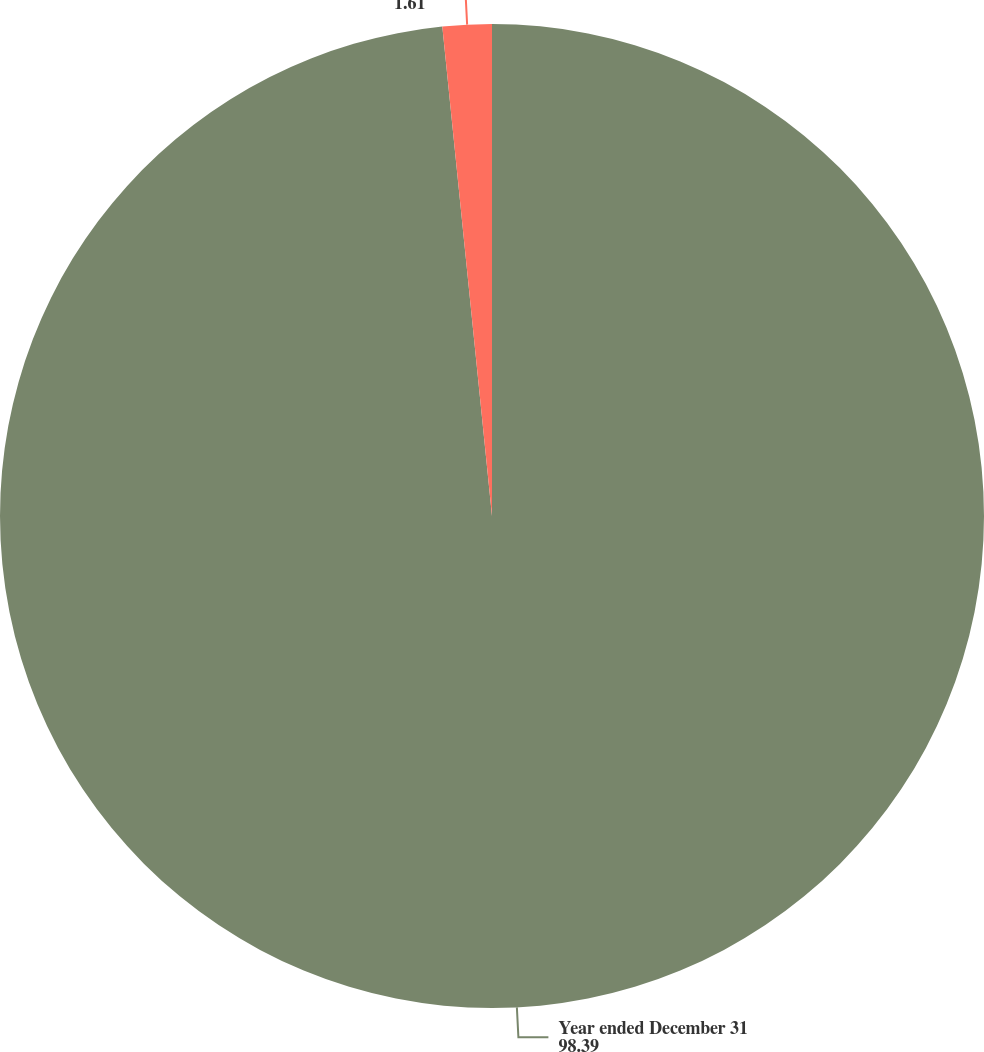Convert chart. <chart><loc_0><loc_0><loc_500><loc_500><pie_chart><fcel>Year ended December 31<fcel>Common dividend payout ratio<nl><fcel>98.39%<fcel>1.61%<nl></chart> 